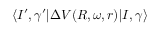<formula> <loc_0><loc_0><loc_500><loc_500>\langle I ^ { \prime } , \gamma ^ { \prime } | \Delta V ( R , \omega , r ) | I , \gamma \rangle</formula> 